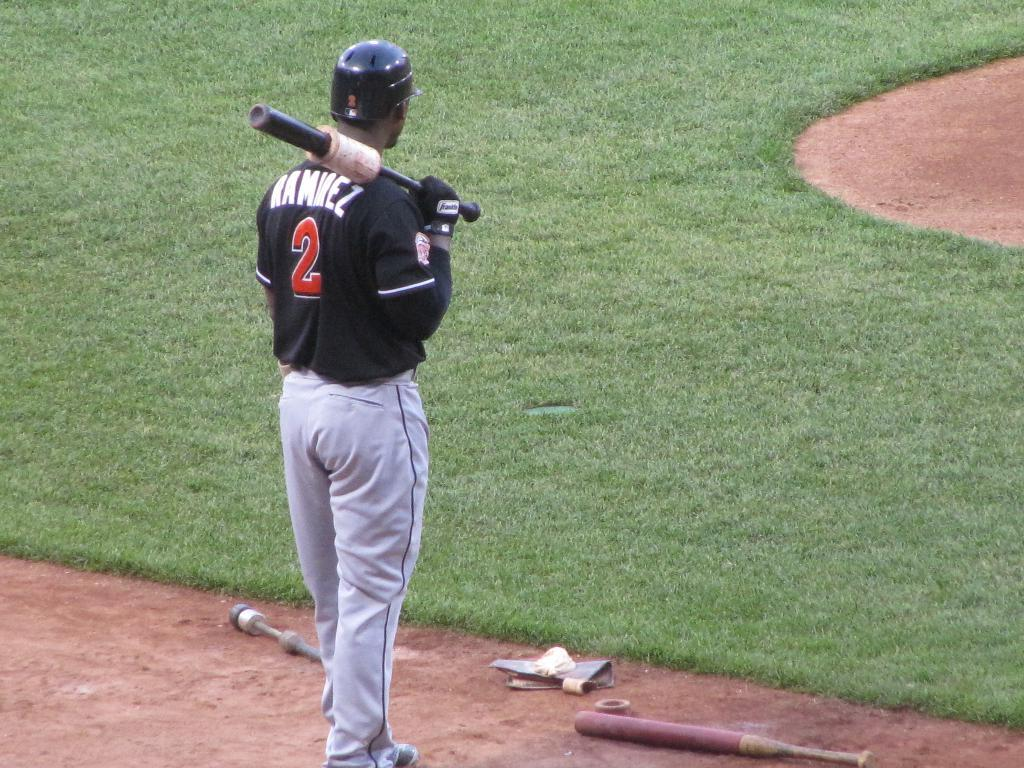Provide a one-sentence caption for the provided image. A baseball player standing on the field with a bat over his shoulder with the name ramirez on his jersey. 